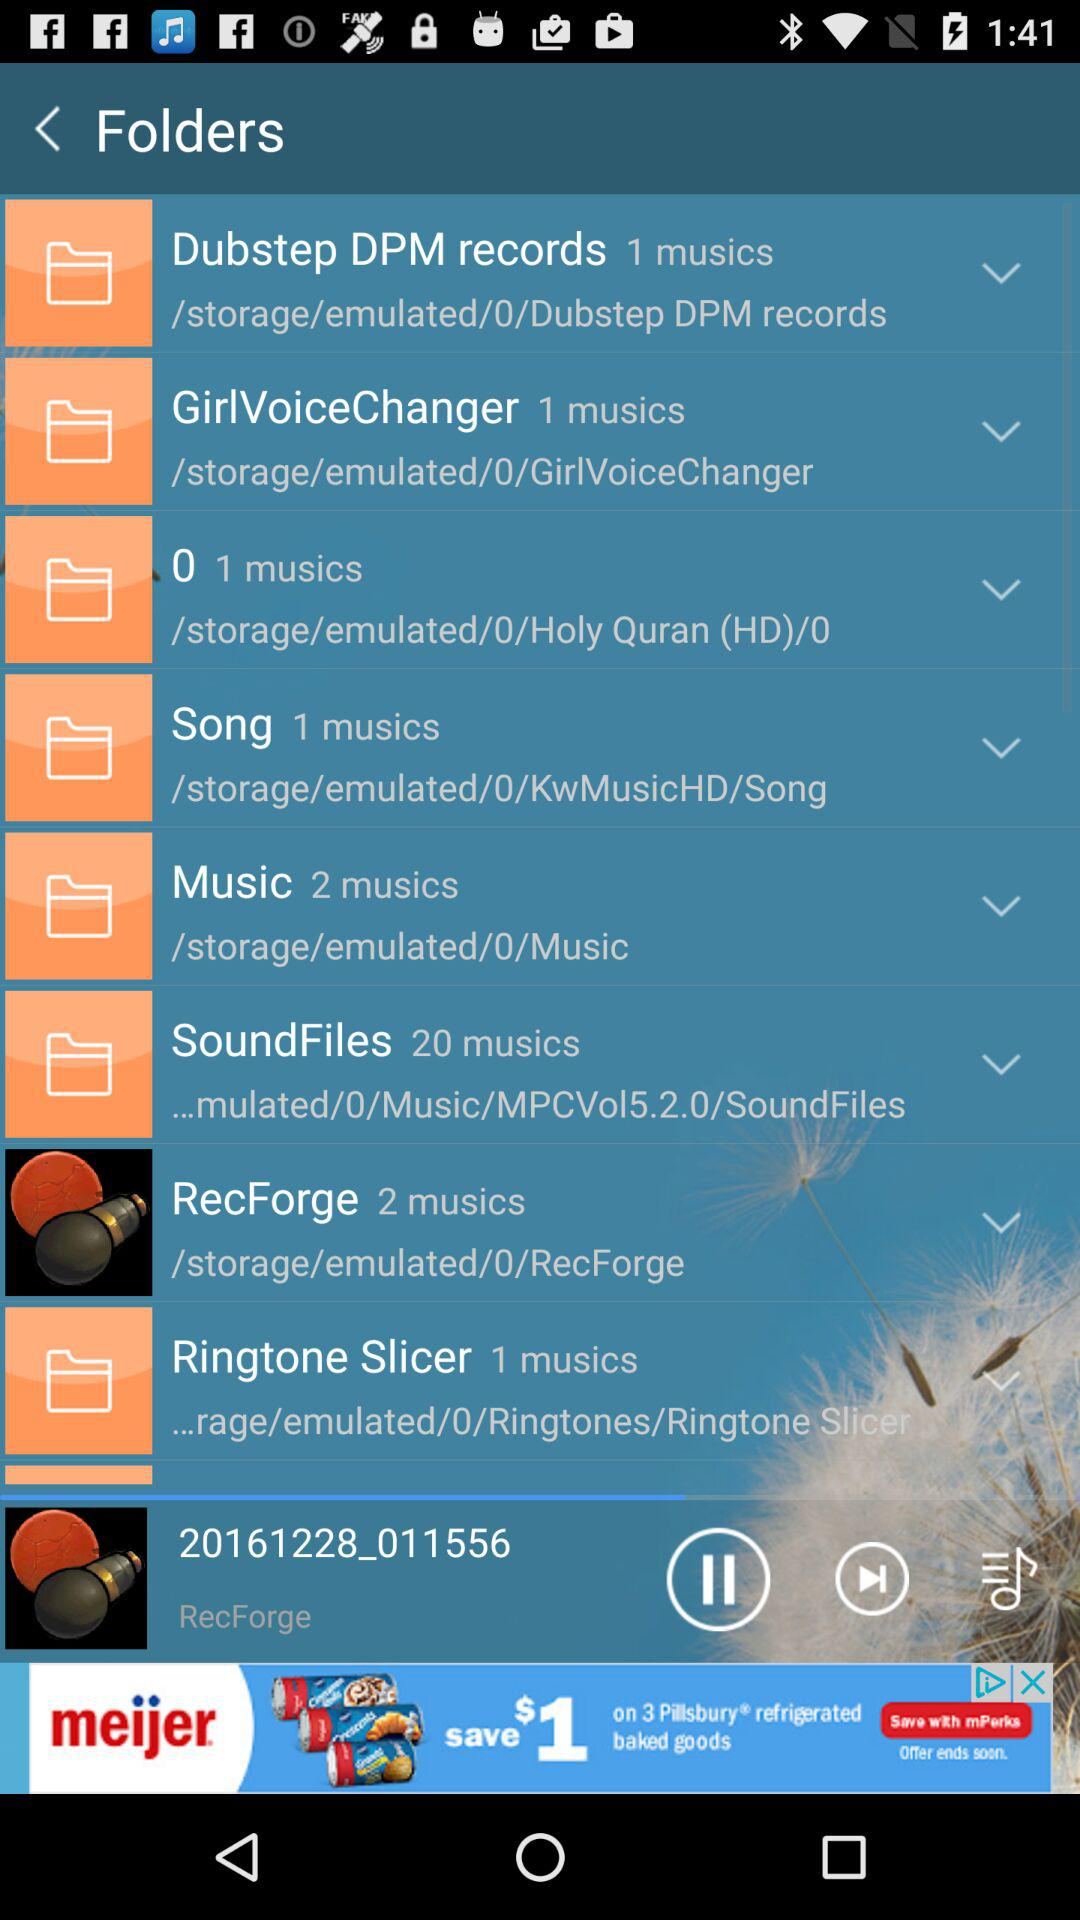What is the number of music files in the "SoundFiles" folder? The number of music files is 20. 